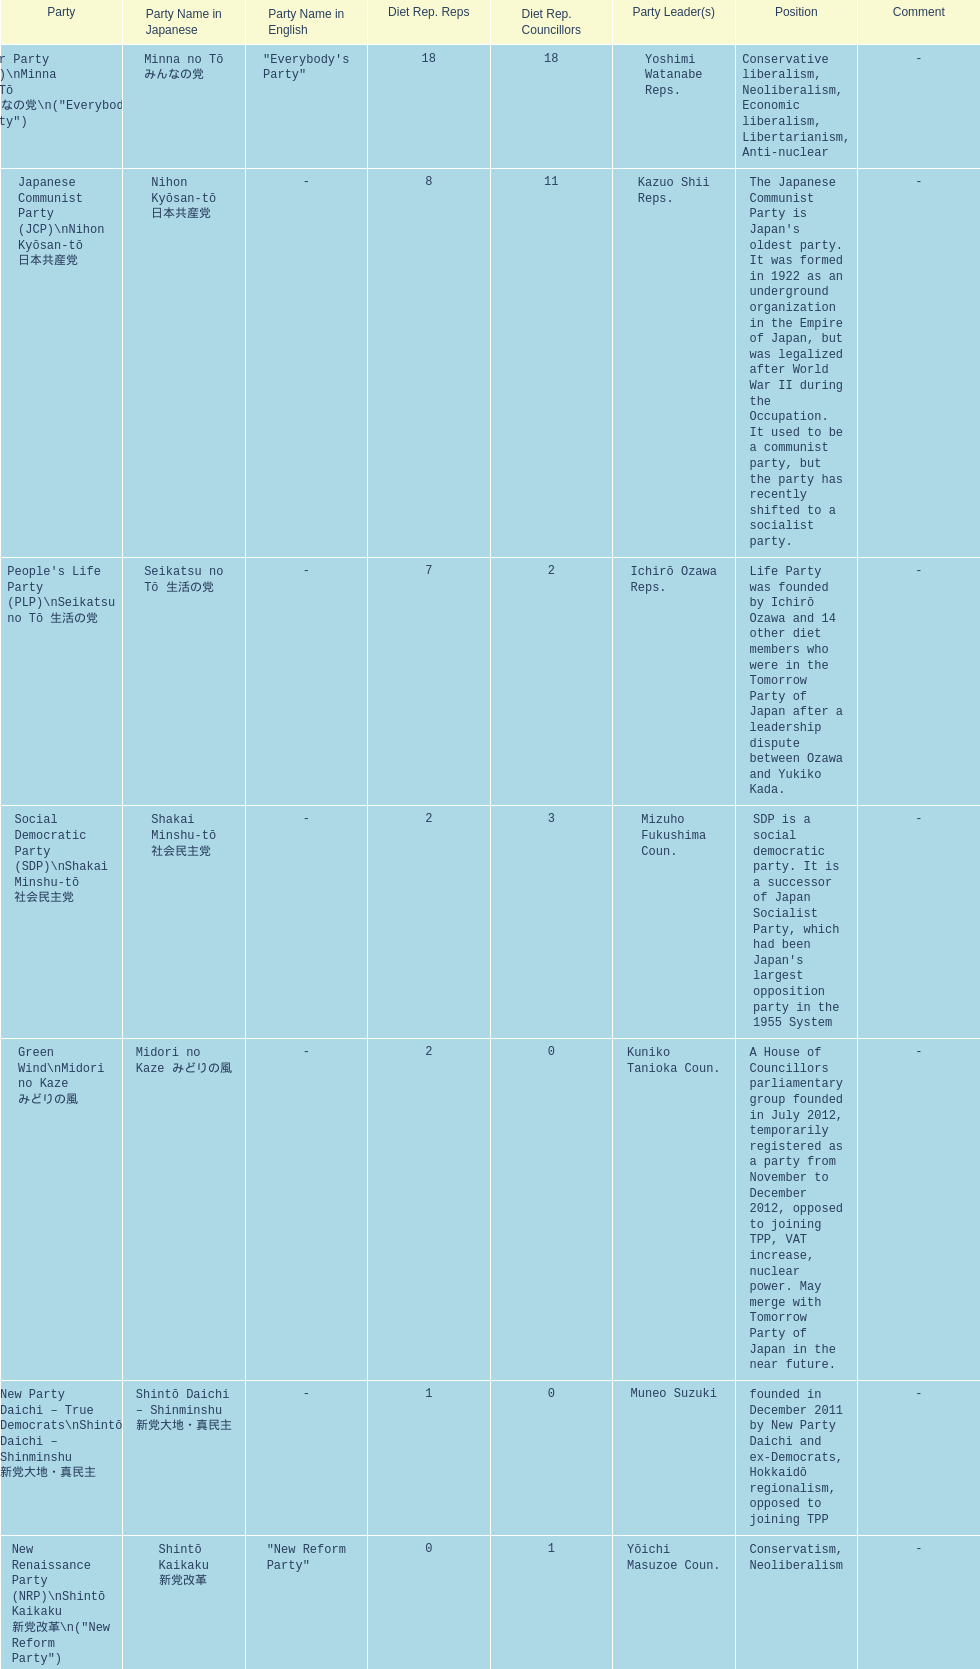How many of these parties currently have no councillors? 2. 